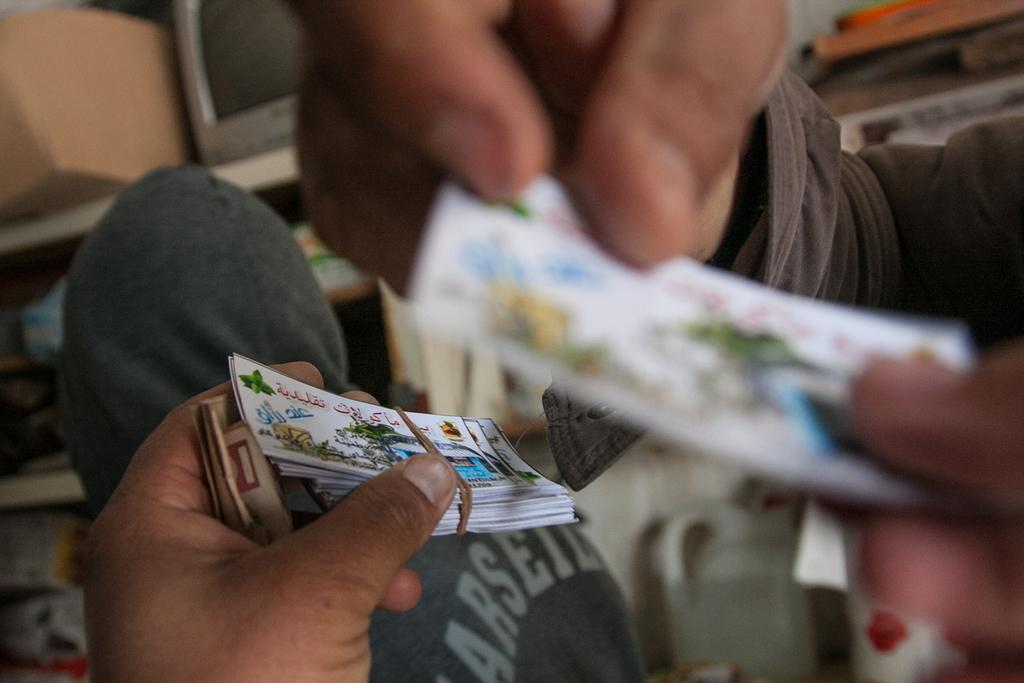Who is present in the image? There is a person in the image. What is the person holding? The person is holding some cards. What can be seen in the background of the image? There is a computer and a carton box in the background of the image. What type of bottle is visible on the person's desk in the image? There is no bottle visible on the person's desk in the image. 